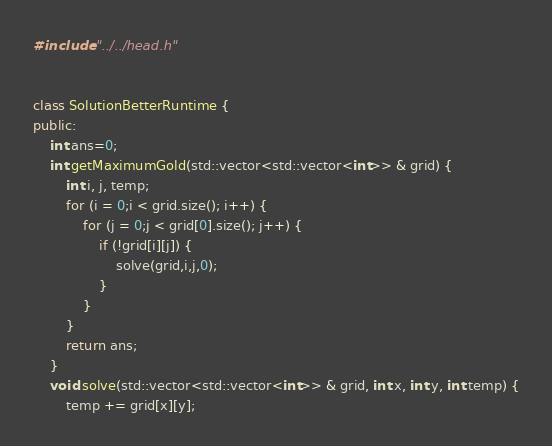<code> <loc_0><loc_0><loc_500><loc_500><_C++_>#include "../../head.h"


class SolutionBetterRuntime {
public:
    int ans=0;
    int getMaximumGold(std::vector<std::vector<int>> & grid) {
        int i, j, temp;
        for (i = 0;i < grid.size(); i++) {
            for (j = 0;j < grid[0].size(); j++) {
                if (!grid[i][j]) {
                    solve(grid,i,j,0);
                }
            }
        }
        return ans;
    }
    void solve(std::vector<std::vector<int>> & grid, int x, int y, int temp) {
        temp += grid[x][y];</code> 